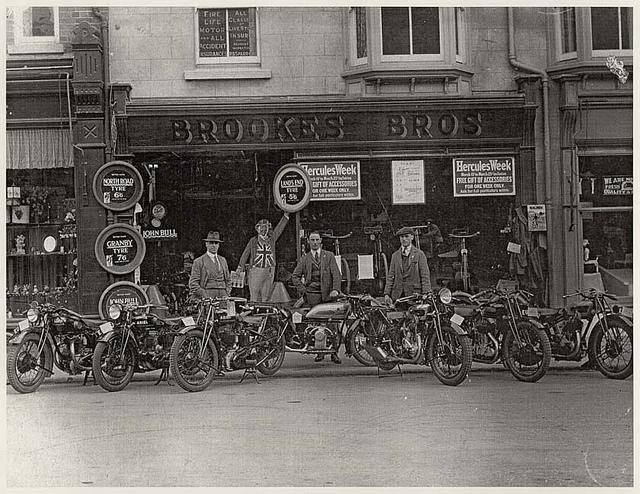How old is this picture?
Short answer required. Old. Is this a modern day photo?
Short answer required. No. How are the bikes standing upright?
Keep it brief. Kickstands. 